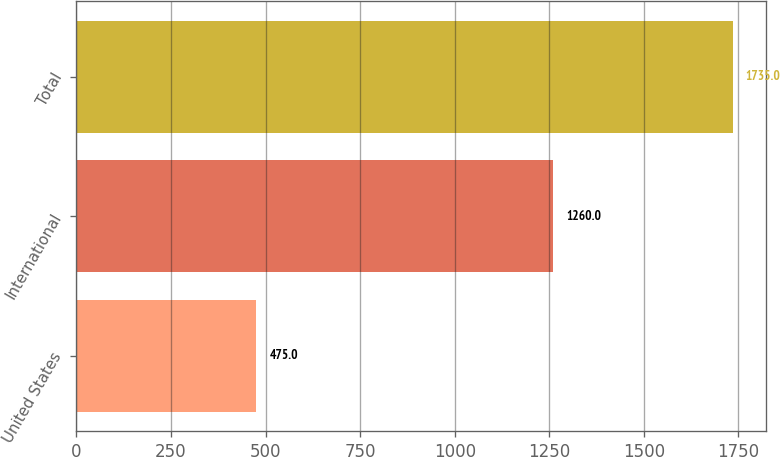Convert chart. <chart><loc_0><loc_0><loc_500><loc_500><bar_chart><fcel>United States<fcel>International<fcel>Total<nl><fcel>475<fcel>1260<fcel>1735<nl></chart> 